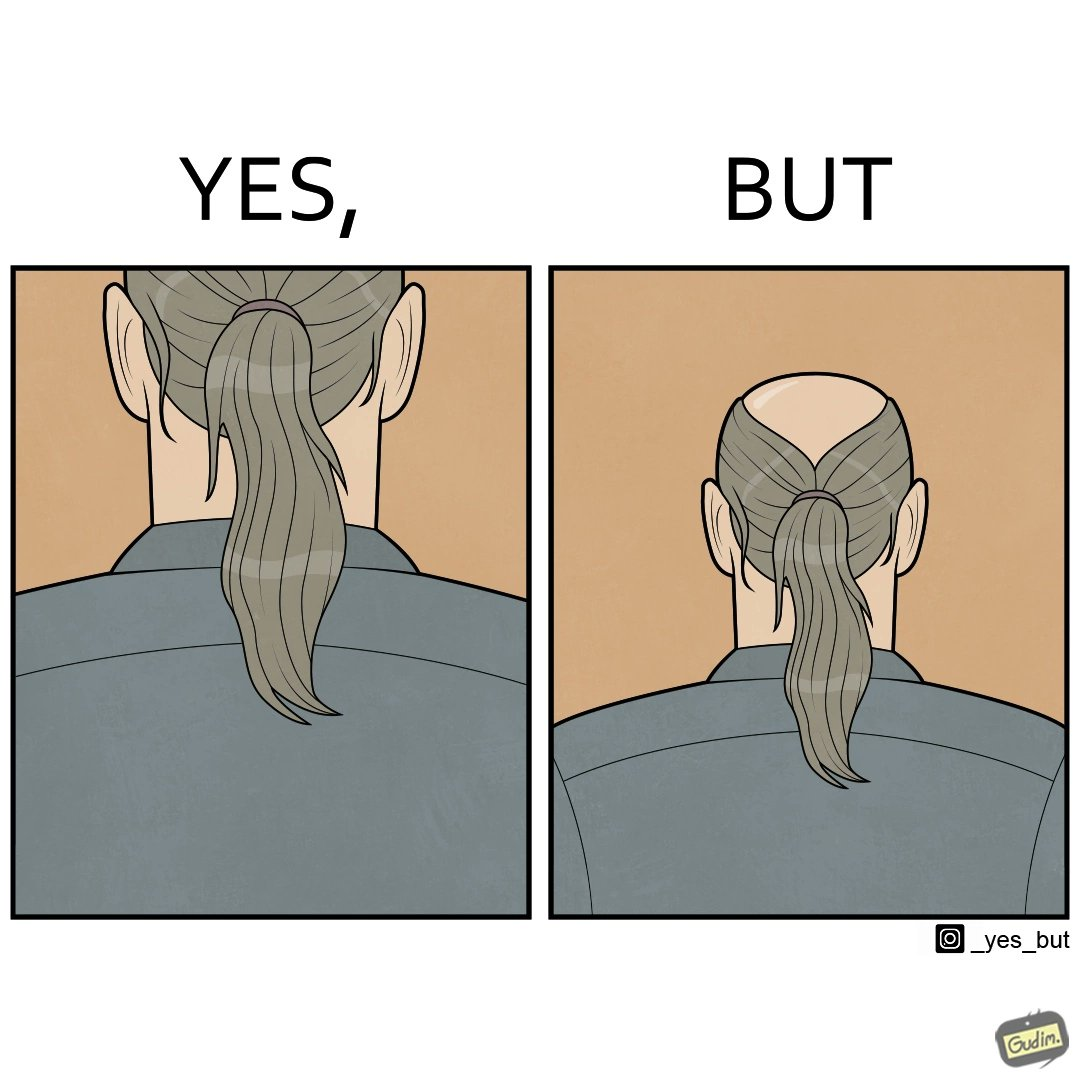Explain why this image is satirical. The images are funny simce they show how people draw conclusions without getting the whole perspective. Here the viewer thinks the subject has beautiful long hair after seeing only the bottom half of the image but once we see the whole image, we realise the subject is half bald 